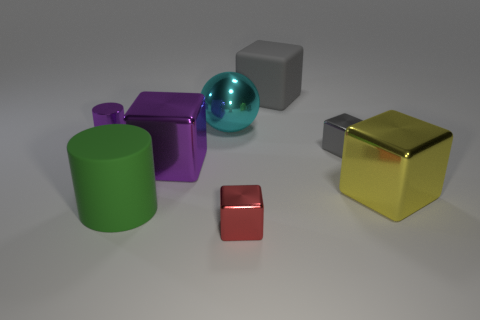What materials do these objects appear to be made of? The objects portray a variety of materials. The cube appears metallic with a matte finish, the sphere has a reflective surface suggestive of polished metal or glass, the cylinder and the cube seem to have a plastic-like matte finish, while the small rectangular object has a satiny surface that could imply a metallic nature as well. 